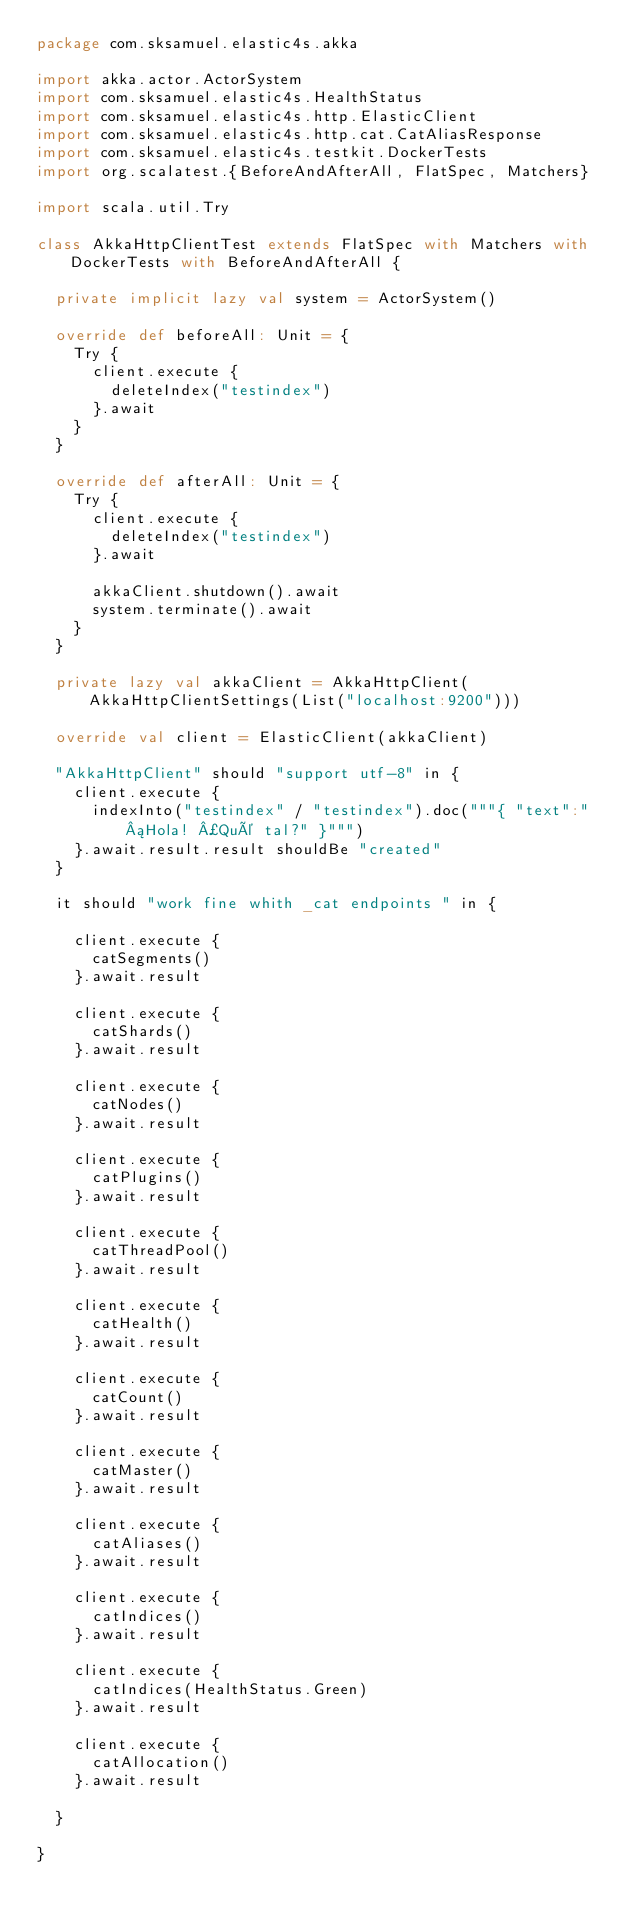<code> <loc_0><loc_0><loc_500><loc_500><_Scala_>package com.sksamuel.elastic4s.akka

import akka.actor.ActorSystem
import com.sksamuel.elastic4s.HealthStatus
import com.sksamuel.elastic4s.http.ElasticClient
import com.sksamuel.elastic4s.http.cat.CatAliasResponse
import com.sksamuel.elastic4s.testkit.DockerTests
import org.scalatest.{BeforeAndAfterAll, FlatSpec, Matchers}

import scala.util.Try

class AkkaHttpClientTest extends FlatSpec with Matchers with DockerTests with BeforeAndAfterAll {

  private implicit lazy val system = ActorSystem()

  override def beforeAll: Unit = {
    Try {
      client.execute {
        deleteIndex("testindex")
      }.await
    }
  }

  override def afterAll: Unit = {
    Try {
      client.execute {
        deleteIndex("testindex")
      }.await

      akkaClient.shutdown().await
      system.terminate().await
    }
  }

  private lazy val akkaClient = AkkaHttpClient(AkkaHttpClientSettings(List("localhost:9200")))

  override val client = ElasticClient(akkaClient)

  "AkkaHttpClient" should "support utf-8" in {
    client.execute {
      indexInto("testindex" / "testindex").doc("""{ "text":"¡Hola! ¿Qué tal?" }""")
    }.await.result.result shouldBe "created"
  }

  it should "work fine whith _cat endpoints " in {

    client.execute {
      catSegments()
    }.await.result

    client.execute {
      catShards()
    }.await.result

    client.execute {
      catNodes()
    }.await.result

    client.execute {
      catPlugins()
    }.await.result

    client.execute {
      catThreadPool()
    }.await.result

    client.execute {
      catHealth()
    }.await.result

    client.execute {
      catCount()
    }.await.result

    client.execute {
      catMaster()
    }.await.result

    client.execute {
      catAliases()
    }.await.result

    client.execute {
      catIndices()
    }.await.result

    client.execute {
      catIndices(HealthStatus.Green)
    }.await.result

    client.execute {
      catAllocation()
    }.await.result

  }

}

</code> 